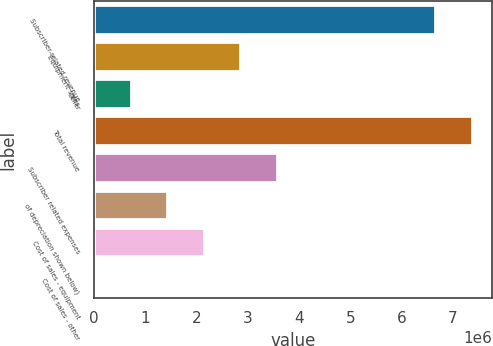<chart> <loc_0><loc_0><loc_500><loc_500><bar_chart><fcel>Subscriber-related revenue<fcel>Equipment sales<fcel>Other<fcel>Total revenue<fcel>Subscriber related expenses<fcel>of depreciation shown below)<fcel>Cost of sales - equipment<fcel>Cost of sales - other<nl><fcel>6.67737e+06<fcel>2.88045e+06<fcel>745060<fcel>7.38917e+06<fcel>3.59224e+06<fcel>1.45686e+06<fcel>2.16865e+06<fcel>33265<nl></chart> 